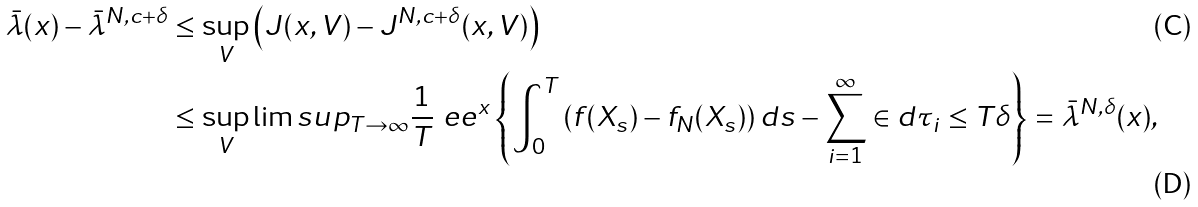Convert formula to latex. <formula><loc_0><loc_0><loc_500><loc_500>\bar { \lambda } ( x ) - \bar { \lambda } ^ { N , c + \delta } & \leq \sup _ { V } \left ( J ( x , V ) - J ^ { N , c + \delta } ( x , V ) \right ) \\ & \leq \sup _ { V } \lim s u p _ { T \to \infty } \frac { 1 } { T } \ e e ^ { x } \left \{ \int _ { 0 } ^ { T } \left ( f ( X _ { s } ) - f _ { N } ( X _ { s } ) \right ) d s - \sum _ { i = 1 } ^ { \infty } \in d { \tau _ { i } \leq T } \delta \right \} = \bar { \lambda } ^ { N , \delta } ( x ) ,</formula> 